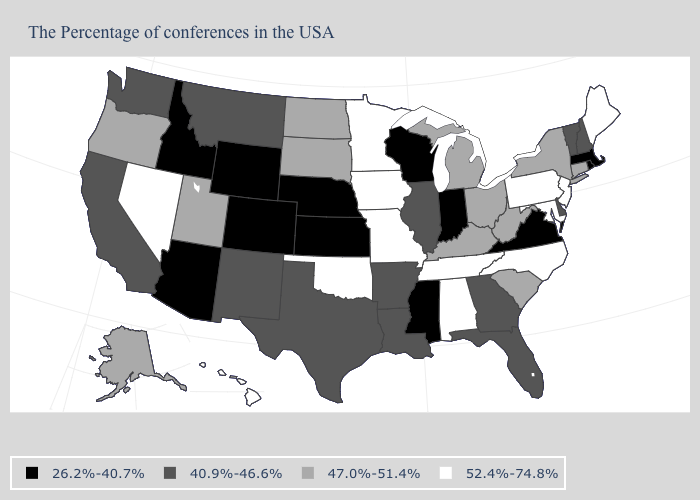Which states hav the highest value in the MidWest?
Keep it brief. Missouri, Minnesota, Iowa. Which states hav the highest value in the South?
Quick response, please. Maryland, North Carolina, Alabama, Tennessee, Oklahoma. Which states have the lowest value in the USA?
Give a very brief answer. Massachusetts, Rhode Island, Virginia, Indiana, Wisconsin, Mississippi, Kansas, Nebraska, Wyoming, Colorado, Arizona, Idaho. Name the states that have a value in the range 26.2%-40.7%?
Write a very short answer. Massachusetts, Rhode Island, Virginia, Indiana, Wisconsin, Mississippi, Kansas, Nebraska, Wyoming, Colorado, Arizona, Idaho. Is the legend a continuous bar?
Write a very short answer. No. Name the states that have a value in the range 26.2%-40.7%?
Answer briefly. Massachusetts, Rhode Island, Virginia, Indiana, Wisconsin, Mississippi, Kansas, Nebraska, Wyoming, Colorado, Arizona, Idaho. Does Alaska have the lowest value in the USA?
Write a very short answer. No. What is the value of Missouri?
Give a very brief answer. 52.4%-74.8%. Among the states that border Florida , which have the lowest value?
Concise answer only. Georgia. How many symbols are there in the legend?
Keep it brief. 4. Among the states that border Minnesota , does Wisconsin have the lowest value?
Write a very short answer. Yes. Among the states that border Minnesota , does Wisconsin have the lowest value?
Answer briefly. Yes. Among the states that border Rhode Island , does Massachusetts have the highest value?
Keep it brief. No. Name the states that have a value in the range 47.0%-51.4%?
Short answer required. Connecticut, New York, South Carolina, West Virginia, Ohio, Michigan, Kentucky, South Dakota, North Dakota, Utah, Oregon, Alaska. What is the value of Delaware?
Short answer required. 40.9%-46.6%. 